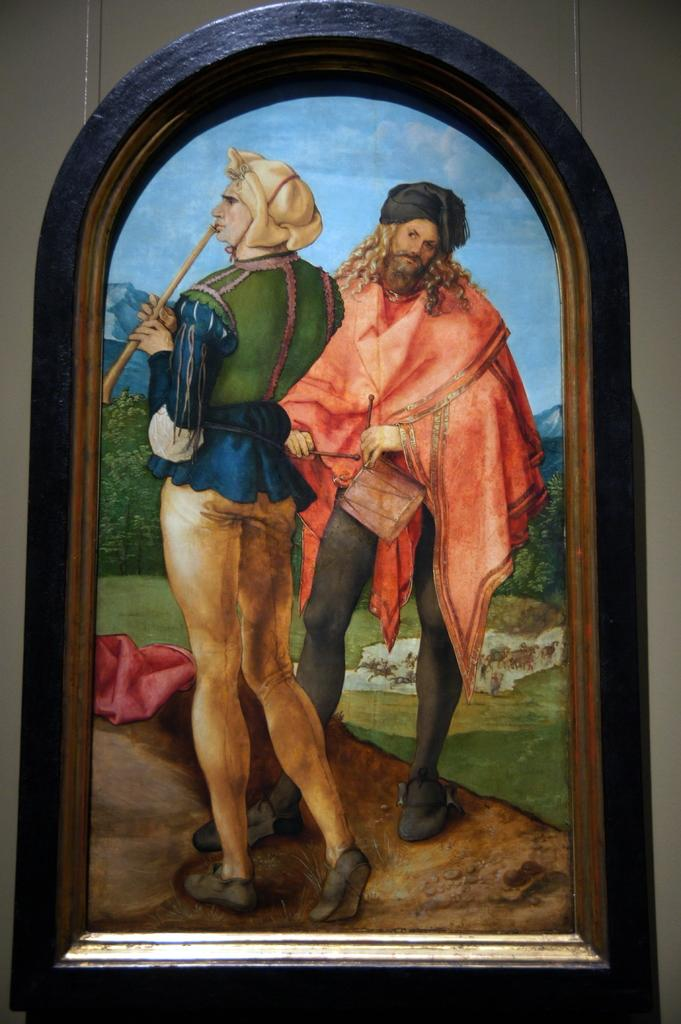What is the main subject of the image? There is a painting in the image. What is depicted in the painting? The painting depicts a man and a woman. Where are the man and woman standing in the painting? The man and woman are standing on a path. What type of surface can be seen beneath the man and woman? There is a grass surface visible in the image. What can be seen in the background of the painting? There are plants, hills, and the sky visible in the background of the image. What type of jewel is the man wearing in the image? There is no mention of a jewel in the image, as the man and woman are depicted in a painting that does not show any jewelry. How many forks can be seen in the image? There are no forks present in the image; it features a painting of a man and a woman standing on a path with a grass surface and a background of plants, hills, and the sky. 